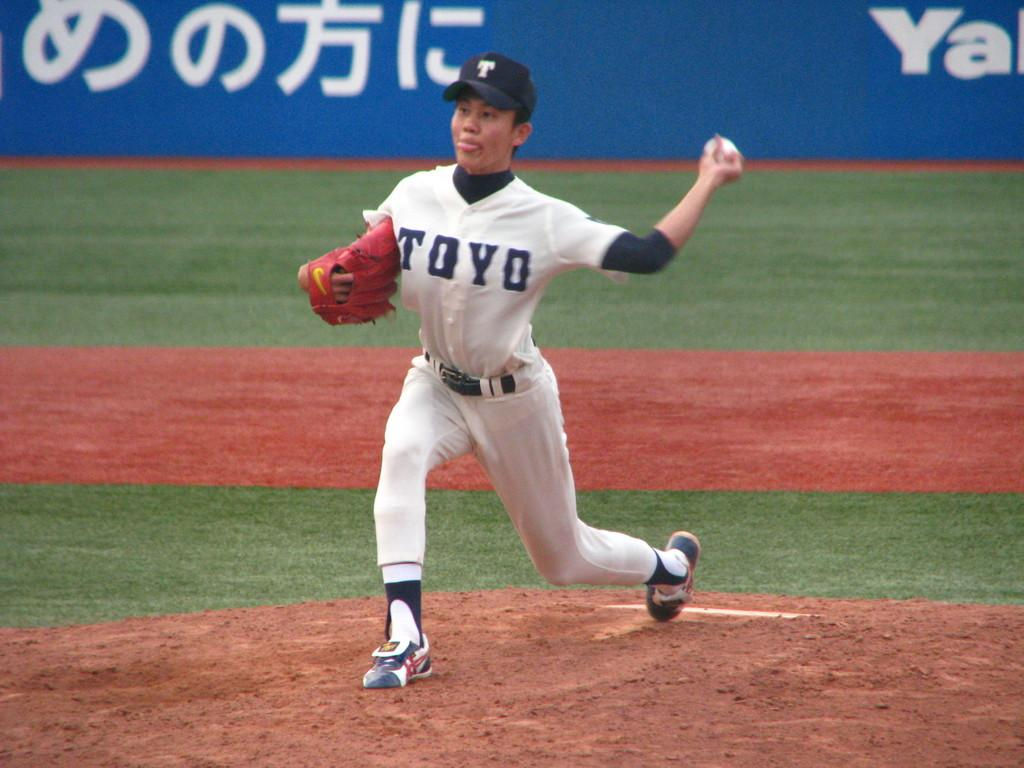<image>
Provide a brief description of the given image. A person throws the ball with a uniform on with the team name Toyo. 